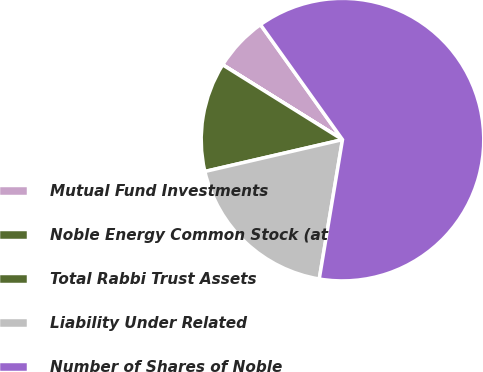Convert chart. <chart><loc_0><loc_0><loc_500><loc_500><pie_chart><fcel>Mutual Fund Investments<fcel>Noble Energy Common Stock (at<fcel>Total Rabbi Trust Assets<fcel>Liability Under Related<fcel>Number of Shares of Noble<nl><fcel>6.25%<fcel>0.01%<fcel>12.5%<fcel>18.75%<fcel>62.49%<nl></chart> 